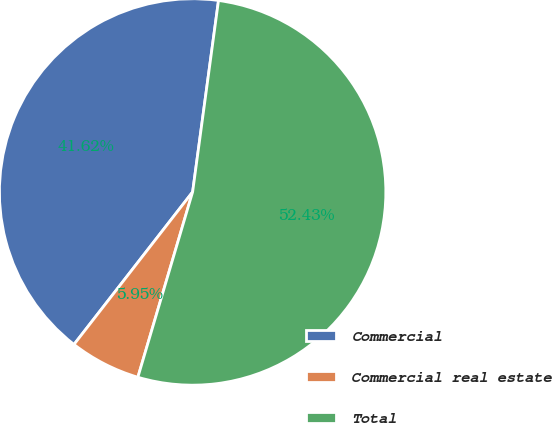Convert chart to OTSL. <chart><loc_0><loc_0><loc_500><loc_500><pie_chart><fcel>Commercial<fcel>Commercial real estate<fcel>Total<nl><fcel>41.62%<fcel>5.95%<fcel>52.44%<nl></chart> 